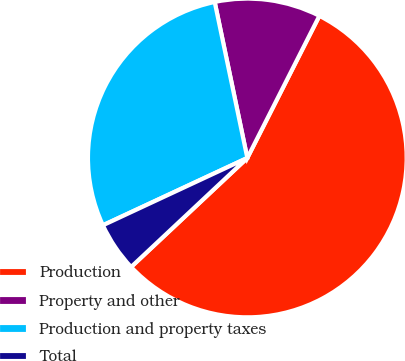<chart> <loc_0><loc_0><loc_500><loc_500><pie_chart><fcel>Production<fcel>Property and other<fcel>Production and property taxes<fcel>Total<nl><fcel>55.54%<fcel>10.75%<fcel>28.66%<fcel>5.05%<nl></chart> 